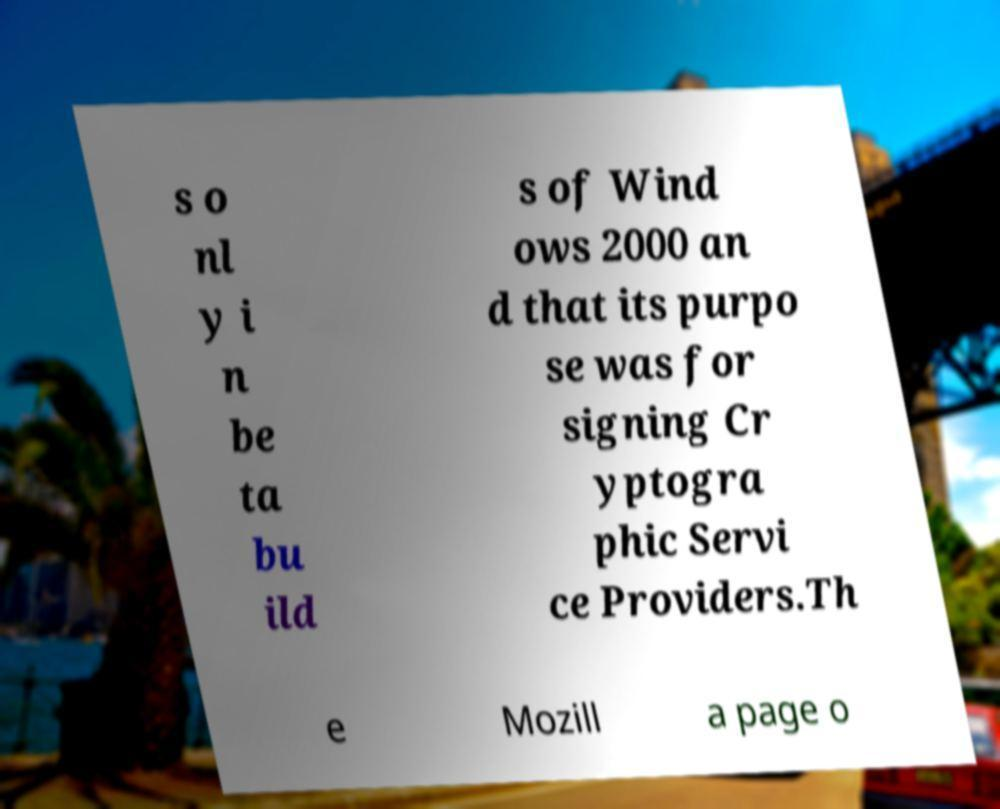Can you accurately transcribe the text from the provided image for me? s o nl y i n be ta bu ild s of Wind ows 2000 an d that its purpo se was for signing Cr yptogra phic Servi ce Providers.Th e Mozill a page o 